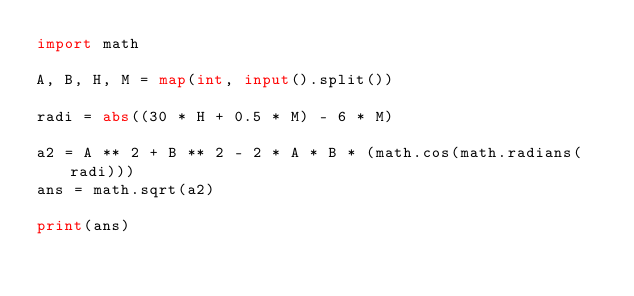<code> <loc_0><loc_0><loc_500><loc_500><_Python_>import math

A, B, H, M = map(int, input().split())

radi = abs((30 * H + 0.5 * M) - 6 * M)

a2 = A ** 2 + B ** 2 - 2 * A * B * (math.cos(math.radians(radi)))
ans = math.sqrt(a2)

print(ans)</code> 